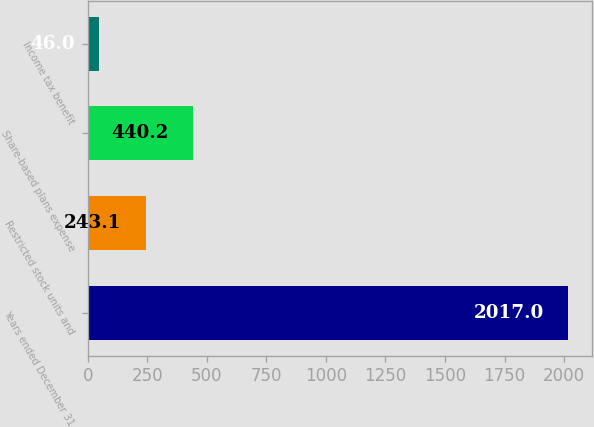Convert chart to OTSL. <chart><loc_0><loc_0><loc_500><loc_500><bar_chart><fcel>Years ended December 31<fcel>Restricted stock units and<fcel>Share-based plans expense<fcel>Income tax benefit<nl><fcel>2017<fcel>243.1<fcel>440.2<fcel>46<nl></chart> 